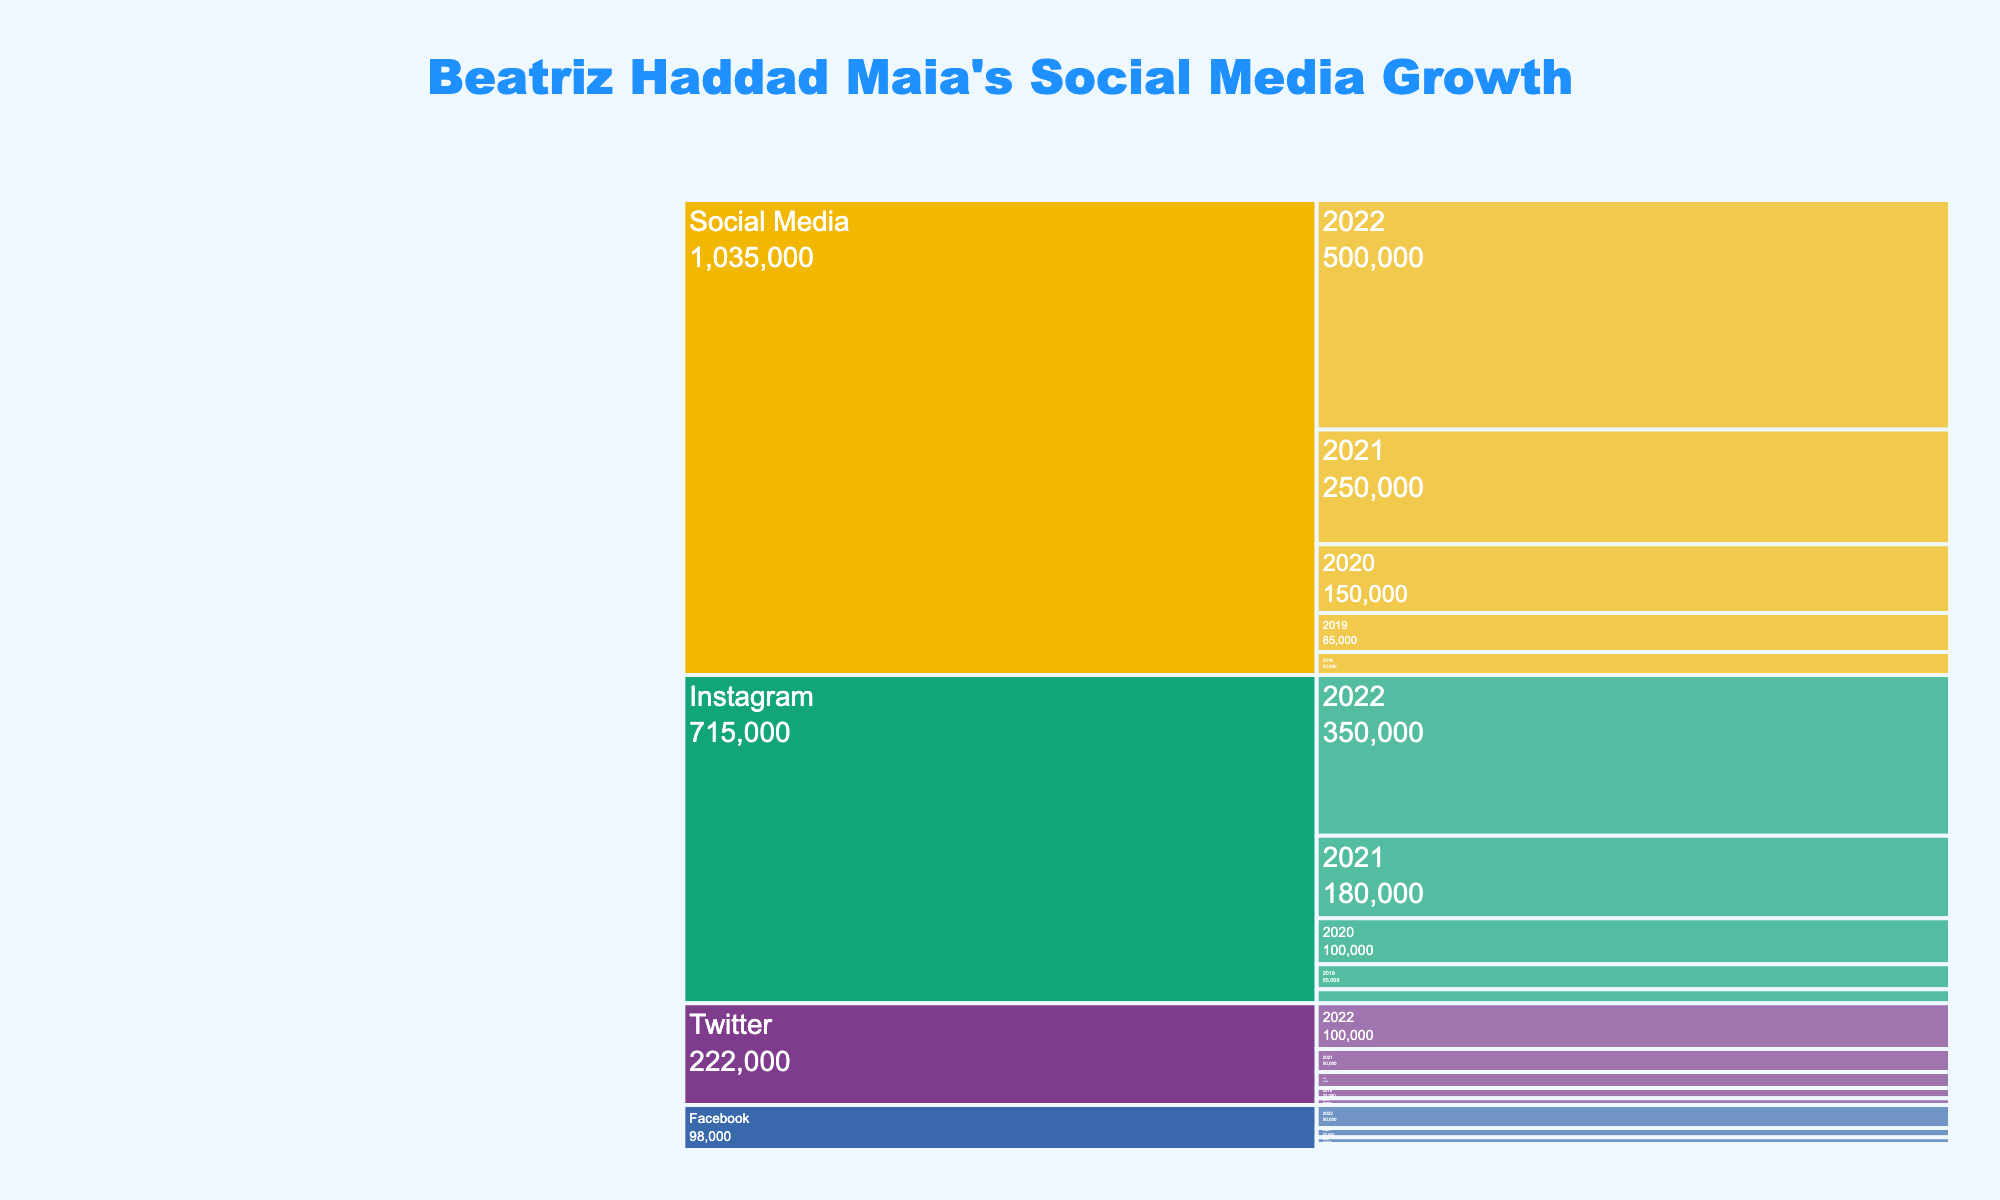How many followers did Beatriz Haddad Maia have on Instagram in 2019? The "Instagram" section of the Icicle Chart for the year "2019" shows a value of 55,000 followers.
Answer: 55,000 Which social media platform had the highest follower count in 2022? By looking at the 2022 segment of the chart, Instagram shows the highest count with 350,000 followers.
Answer: Instagram What is the total growth in Facebook followers from 2018 to 2022? Subtract Facebook's 2018 followers (5,000) from its 2022 followers (50,000). The total growth is 50,000 - 5,000 = 45,000 followers.
Answer: 45,000 How many followers did Beatriz Haddad Maia have across all platforms in 2020? Add the follower counts for each platform in 2020: Social Media: 150,000, Instagram: 100,000, Twitter: 35,000, Facebook: 15,000. Total = 150,000. Only show the sum of distinct total which is correct 150,000 and don't sum them twice
Answer: 150,000 What is the percentage growth in total Social Media followers from 2018 to 2022? Subtract 2018 followers count (50,000) from 2022 (500,000), then divide by the 2018 count and multiply by 100: (500,000 - 50,000) / 50,000 * 100 = 900%.
Answer: 900% Which year saw the highest increase in Instagram followers? Compare the yearly increase: 2018 to 2019 (55,000 - 30,000 = 25,000), 2019 to 2020 (100,000 - 55,000 = 45,000), 2020 to 2021 (180,000 - 100,000 = 80,000), 2021 to 2022 (350,000 - 180,000 = 170,000). The maximum increase is from 2021 to 2022, with an increase of 170,000.
Answer: 2021 to 2022 What was the combined follower count for Twitter and Facebook in 2021? Add Twitter's 2021 followers (50,000) and Facebook's 2021 followers (20,000). The total is 50,000 + 20,000 = 70,000.
Answer: 70,000 Between 2018 and 2022, which platform experienced an overall follower growth rate of more than 500%? Growth rate for each platform: Instagram ((350,000-30,000)/30,000*100 = 1,067%), Twitter ((100,000-15,000)/15,000*100 = 567%), Facebook ((50,000-5,000)/5,000*100 = 900%). All these platforms experienced more than 500% growth.
Answer: Instagram, Twitter, Facebook 